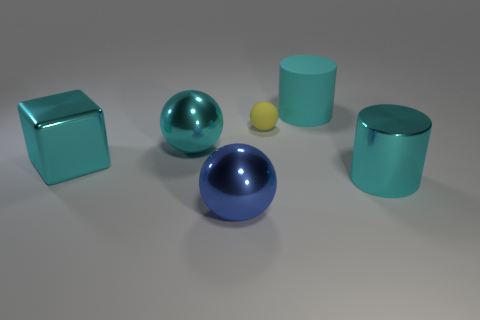Subtract all matte spheres. How many spheres are left? 2 Subtract all blue spheres. How many spheres are left? 2 Subtract all cubes. How many objects are left? 5 Subtract 1 cubes. How many cubes are left? 0 Subtract all cyan balls. How many brown cylinders are left? 0 Subtract all big green shiny cylinders. Subtract all balls. How many objects are left? 3 Add 2 big cyan cubes. How many big cyan cubes are left? 3 Add 2 tiny blue rubber blocks. How many tiny blue rubber blocks exist? 2 Add 4 brown blocks. How many objects exist? 10 Subtract 0 yellow cubes. How many objects are left? 6 